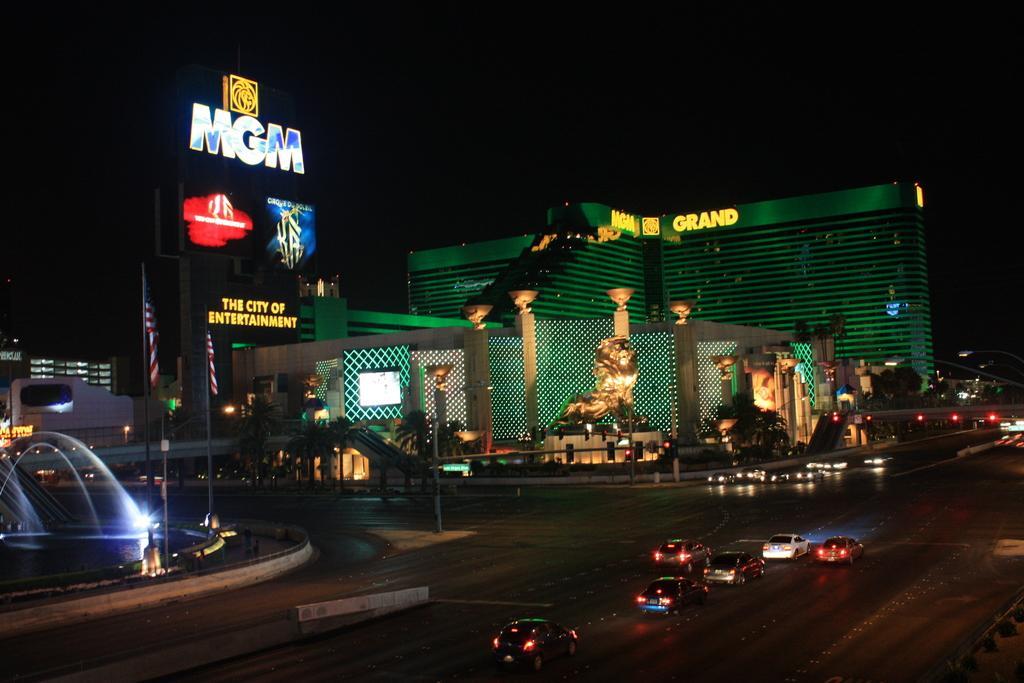Could you give a brief overview of what you see in this image? In the foreground I can see fleets of vehicles, poles, flags on the road, fountain, plants, statue, pillars and buildings. At the top I can see a board, screen and the sky. This image is taken may be during night. 